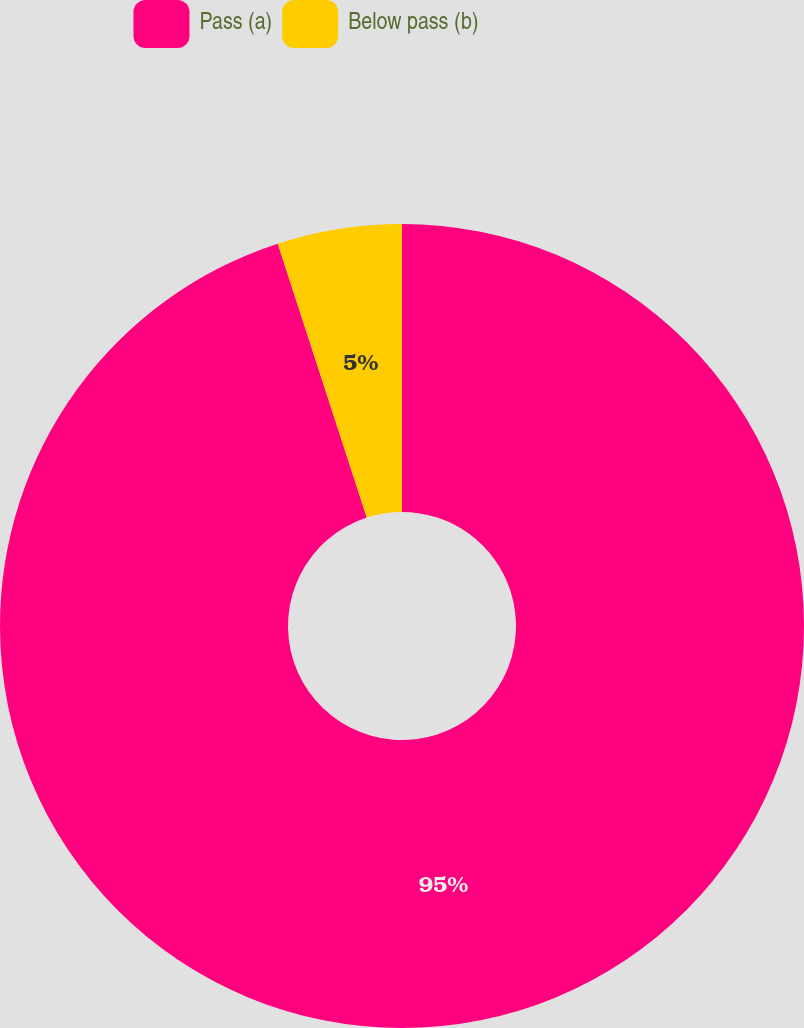Convert chart. <chart><loc_0><loc_0><loc_500><loc_500><pie_chart><fcel>Pass (a)<fcel>Below pass (b)<nl><fcel>95.0%<fcel>5.0%<nl></chart> 